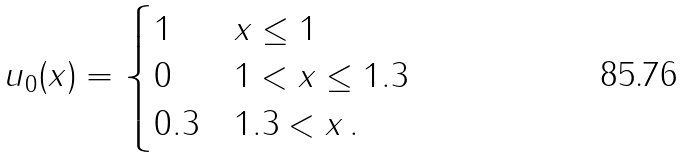<formula> <loc_0><loc_0><loc_500><loc_500>u _ { 0 } ( x ) = \begin{cases} 1 & x \leq 1 \\ 0 & 1 < x \leq 1 . 3 \\ 0 . 3 & 1 . 3 < x \, . \end{cases}</formula> 